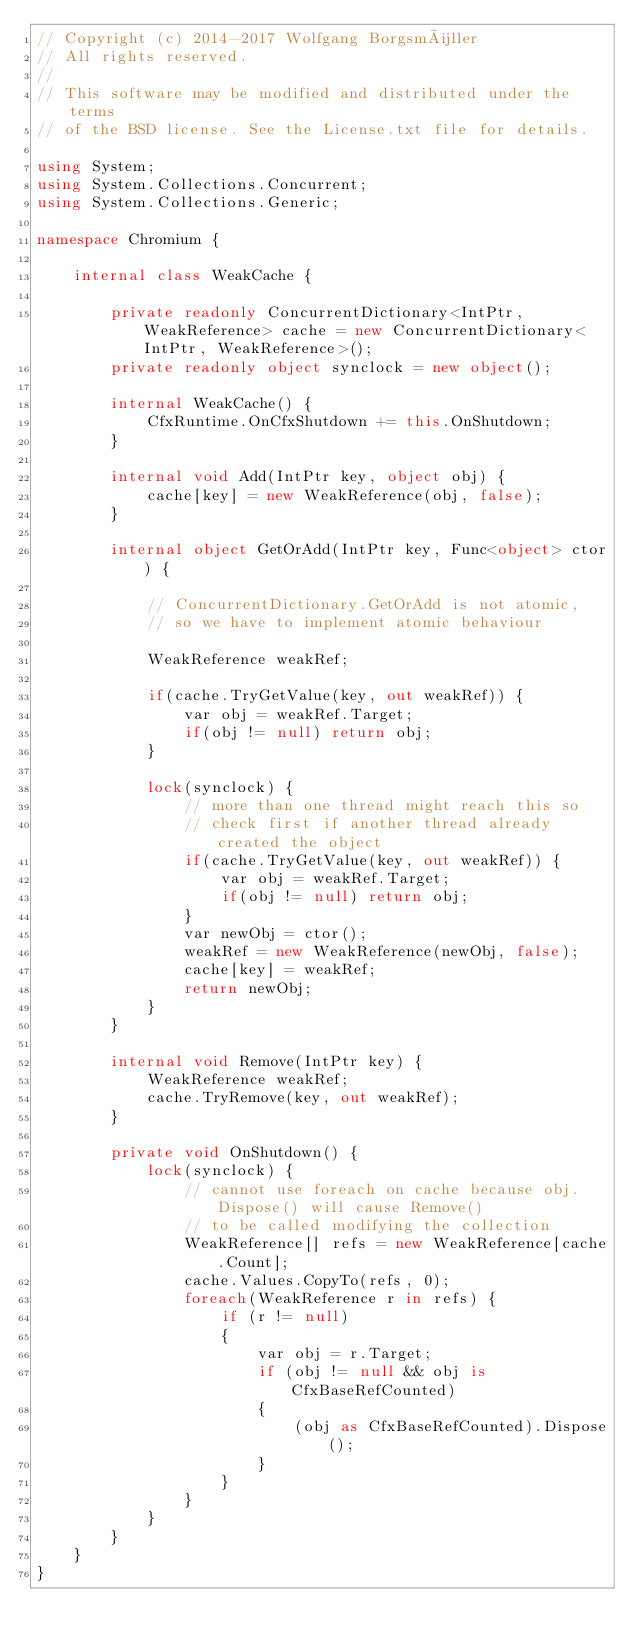<code> <loc_0><loc_0><loc_500><loc_500><_C#_>// Copyright (c) 2014-2017 Wolfgang Borgsmüller
// All rights reserved.
// 
// This software may be modified and distributed under the terms
// of the BSD license. See the License.txt file for details.

using System;
using System.Collections.Concurrent;
using System.Collections.Generic;

namespace Chromium {

    internal class WeakCache {

        private readonly ConcurrentDictionary<IntPtr, WeakReference> cache = new ConcurrentDictionary<IntPtr, WeakReference>();
        private readonly object synclock = new object();

        internal WeakCache() {
            CfxRuntime.OnCfxShutdown += this.OnShutdown;
        }

        internal void Add(IntPtr key, object obj) {
            cache[key] = new WeakReference(obj, false);
        }

        internal object GetOrAdd(IntPtr key, Func<object> ctor) {

            // ConcurrentDictionary.GetOrAdd is not atomic, 
            // so we have to implement atomic behaviour

            WeakReference weakRef;

            if(cache.TryGetValue(key, out weakRef)) {
                var obj = weakRef.Target;
                if(obj != null) return obj;
            }

            lock(synclock) {
                // more than one thread might reach this so
                // check first if another thread already created the object
                if(cache.TryGetValue(key, out weakRef)) {
                    var obj = weakRef.Target;
                    if(obj != null) return obj;
                }
                var newObj = ctor();
                weakRef = new WeakReference(newObj, false);
                cache[key] = weakRef;
                return newObj;
            }
        }

        internal void Remove(IntPtr key) {
            WeakReference weakRef;
            cache.TryRemove(key, out weakRef);
        }

        private void OnShutdown() {
            lock(synclock) {
                // cannot use foreach on cache because obj.Dispose() will cause Remove()
                // to be called modifying the collection
                WeakReference[] refs = new WeakReference[cache.Count];
                cache.Values.CopyTo(refs, 0);
                foreach(WeakReference r in refs) {
                    if (r != null)
                    {
                        var obj = r.Target;
                        if (obj != null && obj is CfxBaseRefCounted)
                        {
                            (obj as CfxBaseRefCounted).Dispose();
                        }
                    }
                }
            }
        }
    }
}
</code> 